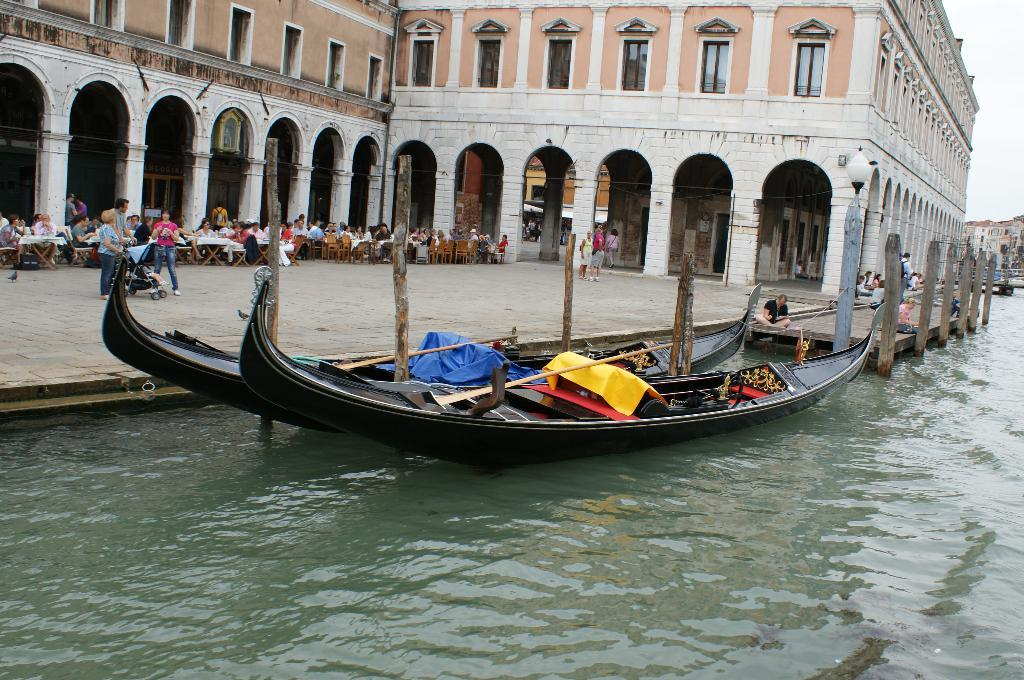What can be seen on the water in the image? There are two boats on the water in the image. What structure is located to the left of the image? There is a building to the left of the image. What are the people in the image doing? Many persons are sitting in chairs near tables. What type of calculator is being used by the person sitting near the table? There is no calculator present in the image; people are sitting near tables, but no calculators are visible. What book is the person on the boat reading? There is no book present in the image; the focus is on the boats, building, and people sitting near tables. 